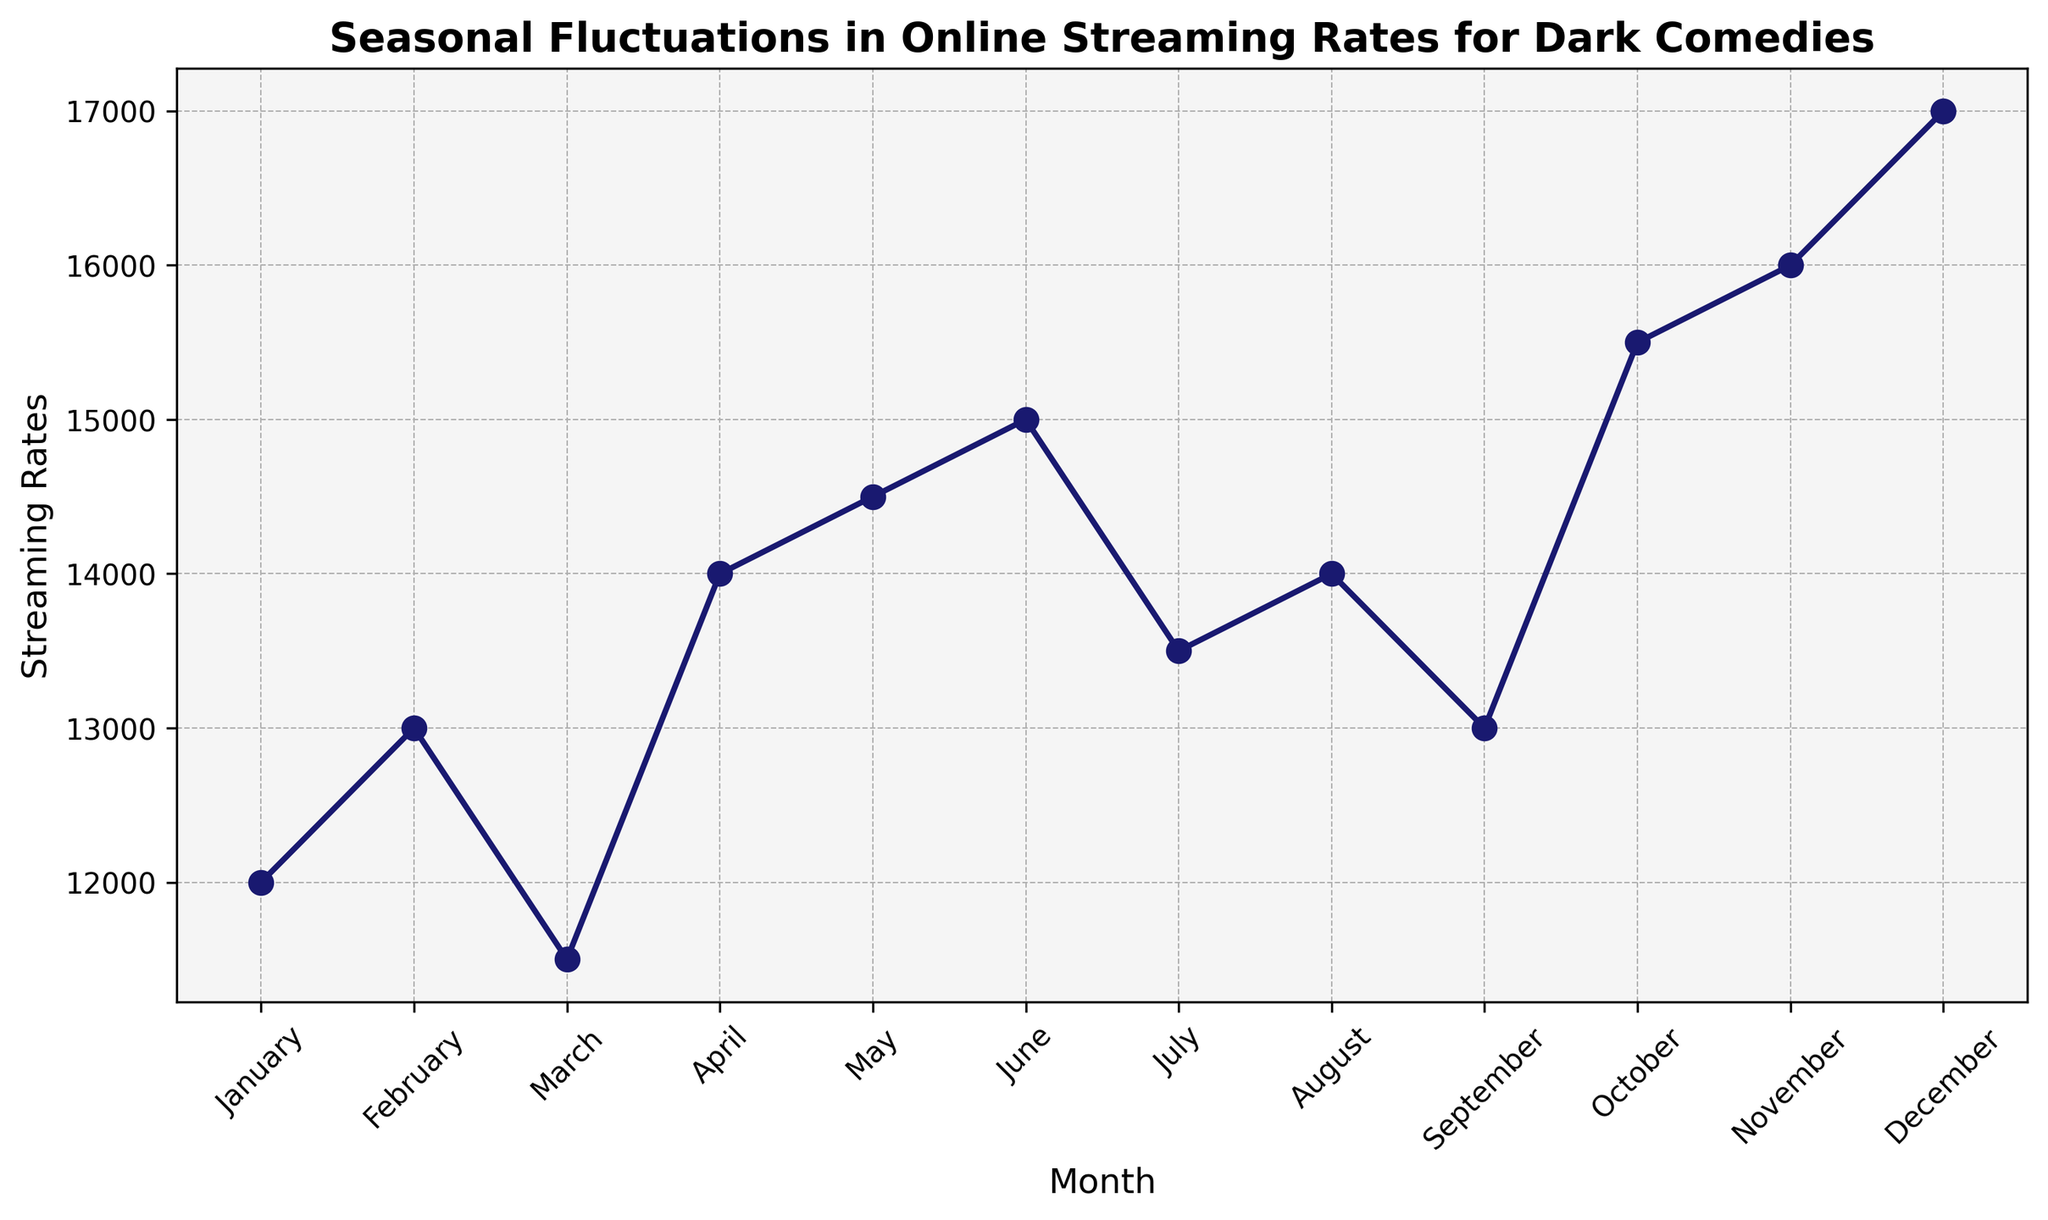How does the online streaming rate in December compare to January? We compare the streaming rates directly from the figure. December has 17000, and January has 12000. So, December is higher.
Answer: December is higher What's the total streaming rate for the first quarter of the year? Sum the streaming rates for January, February, and March: 12000 + 13000 + 11500 = 36500.
Answer: 36500 When did the streaming rates reach their lowest point? By looking at the figure, we can see that March has the lowest streaming rate of 11500.
Answer: March What's the difference in streaming rates between the highest and lowest points in the year? The highest rate is in December (17000), and the lowest is in March (11500). The difference is 17000 - 11500 = 5500.
Answer: 5500 How does the streaming rate in June compare to May? The rate in May is 14500 and in June is 15000. Since 15000 is greater than 14500, June is higher than May.
Answer: June is higher What is the median streaming rate across the year? Arrange the streaming rates in ascending order and find the middle value: [11500, 12000, 13000, 13000, 13500, 14000, 14000, 14500, 15000, 15500, 16000, 17000]. The median is the average of the 6th and 7th values: (14000 + 14000) / 2 = 14000.
Answer: 14000 Did the streaming rate in October increase or decrease compared to September? Looking at the figure, the rate in September is 13000 and in October is 15500. Since 15500 is greater than 13000, it increased.
Answer: Increased Which month shows the highest increase in streaming rates compared to the previous month? Check the differences between successive months: February-January (1000), April-March (2500), May-April (500), etc. The highest increase is between March and April (2500).
Answer: April What's the average streaming rate for the second half of the year? Sum the streaming rates from July to December and divide by 6: (13500 + 14000 + 13000 + 15500 + 16000 + 17000) / 6 = 14833.33.
Answer: 14833.33 What is the overall trend in streaming rates throughout the year? Observing the figure, we see a general increase from January to December with fluctuations in between.
Answer: Increasing 